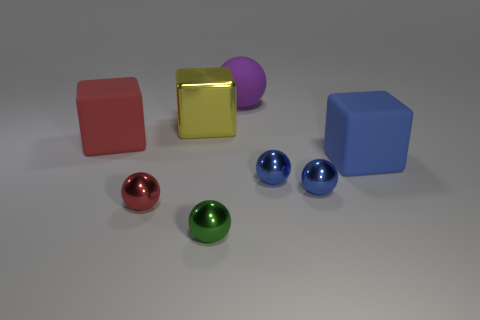Subtract all green spheres. How many spheres are left? 4 Subtract all large matte balls. How many balls are left? 4 Add 2 yellow cylinders. How many objects exist? 10 Subtract all cyan balls. Subtract all blue cylinders. How many balls are left? 5 Subtract all spheres. How many objects are left? 3 Subtract all big rubber balls. Subtract all large red rubber objects. How many objects are left? 6 Add 4 red blocks. How many red blocks are left? 5 Add 5 big green shiny things. How many big green shiny things exist? 5 Subtract 1 red blocks. How many objects are left? 7 